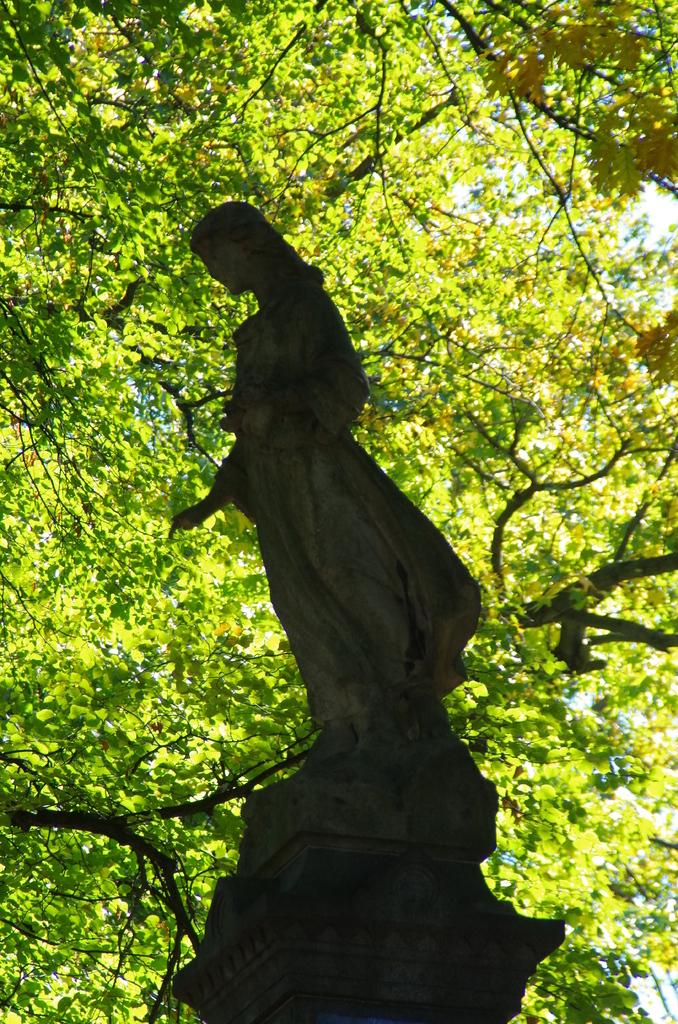What is the main subject in the picture? There is a statue in the picture. What can be seen in the background of the picture? There are trees or tree branches in the background of the picture. What type of education is being taught in the statue? The statue does not depict any educational content or teach any subjects. 